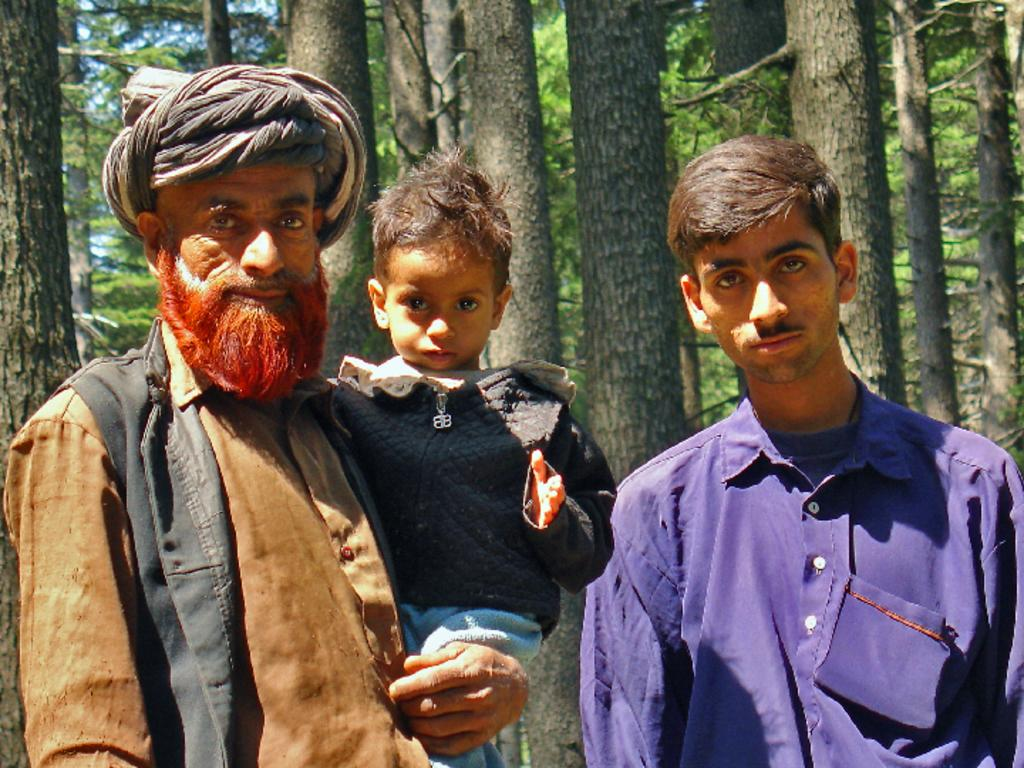How many people are in the image? There are two men in the image. What is one of the men doing in the image? One of the men is carrying a boy. On which side of the image is the man carrying the boy? The man carrying the boy is on the left side. What can be seen in the background of the image? There are trees in the background of the image. How many teeth can be seen in the image? There are no teeth visible in the image. What type of bird is present in the image? There is no bird, including a turkey, present in the image. 